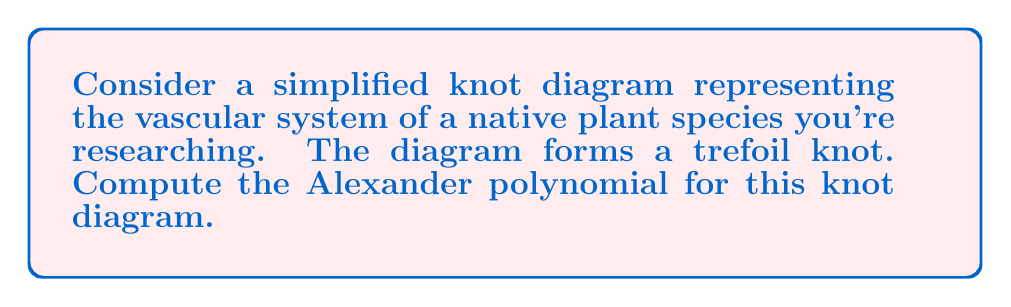Help me with this question. To compute the Alexander polynomial for the trefoil knot representing the plant's vascular system, we'll follow these steps:

1. Label the arcs and crossings of the trefoil knot:
[asy]
import geometry;

pair A=(0,1), B=(0.866,-0.5), C=(-0.866,-0.5);
draw(A--B--C--cycle,linewidth(1));
draw(A--C,linewidth(1));
draw(B--A,linewidth(1));
draw(C--B,linewidth(1));

label("x", (0.5,0.5), E);
label("y", (-0.5,0.5), W);
label("z", (0,-.75), S);

label("1", (0.6,-0.1), SE);
label("2", (-0.6,-0.1), SW);
label("3", (0,0.8), N);
[/asy]

2. Create the Alexandermatrix using the labeling:
$$\begin{pmatrix} 
1-t & -1 & t \\
t & 1-t & -1 \\
-1 & t & 1-t
\end{pmatrix}$$

3. Calculate the determinant of any 2x2 minor of this matrix. We'll use the minor formed by deleting the third row and third column:
$$\det\begin{pmatrix}
1-t & -1 \\
t & 1-t
\end{pmatrix}$$

4. Expand the determinant:
$$(1-t)(1-t) - (-1)(t) = 1-2t+t^2+t = 1-t+t^2$$

5. Normalize the polynomial by multiplying by $\pm t^k$ to ensure the lowest degree term is a constant and the highest degree coefficient is positive:
$$t^{-1}(1-t+t^2) = t^{-1} - 1 + t$$

This is the Alexander polynomial for the trefoil knot.
Answer: $\Delta(t) = t^{-1} - 1 + t$ 